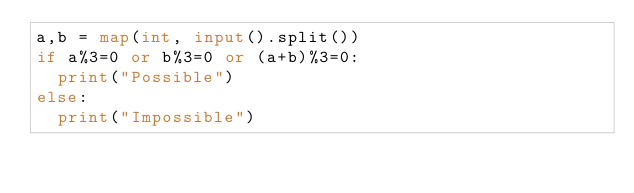Convert code to text. <code><loc_0><loc_0><loc_500><loc_500><_Python_>a,b = map(int, input().split())
if a%3=0 or b%3=0 or (a+b)%3=0:
  print("Possible")
else:
  print("Impossible")</code> 